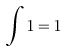<formula> <loc_0><loc_0><loc_500><loc_500>\int 1 = 1</formula> 